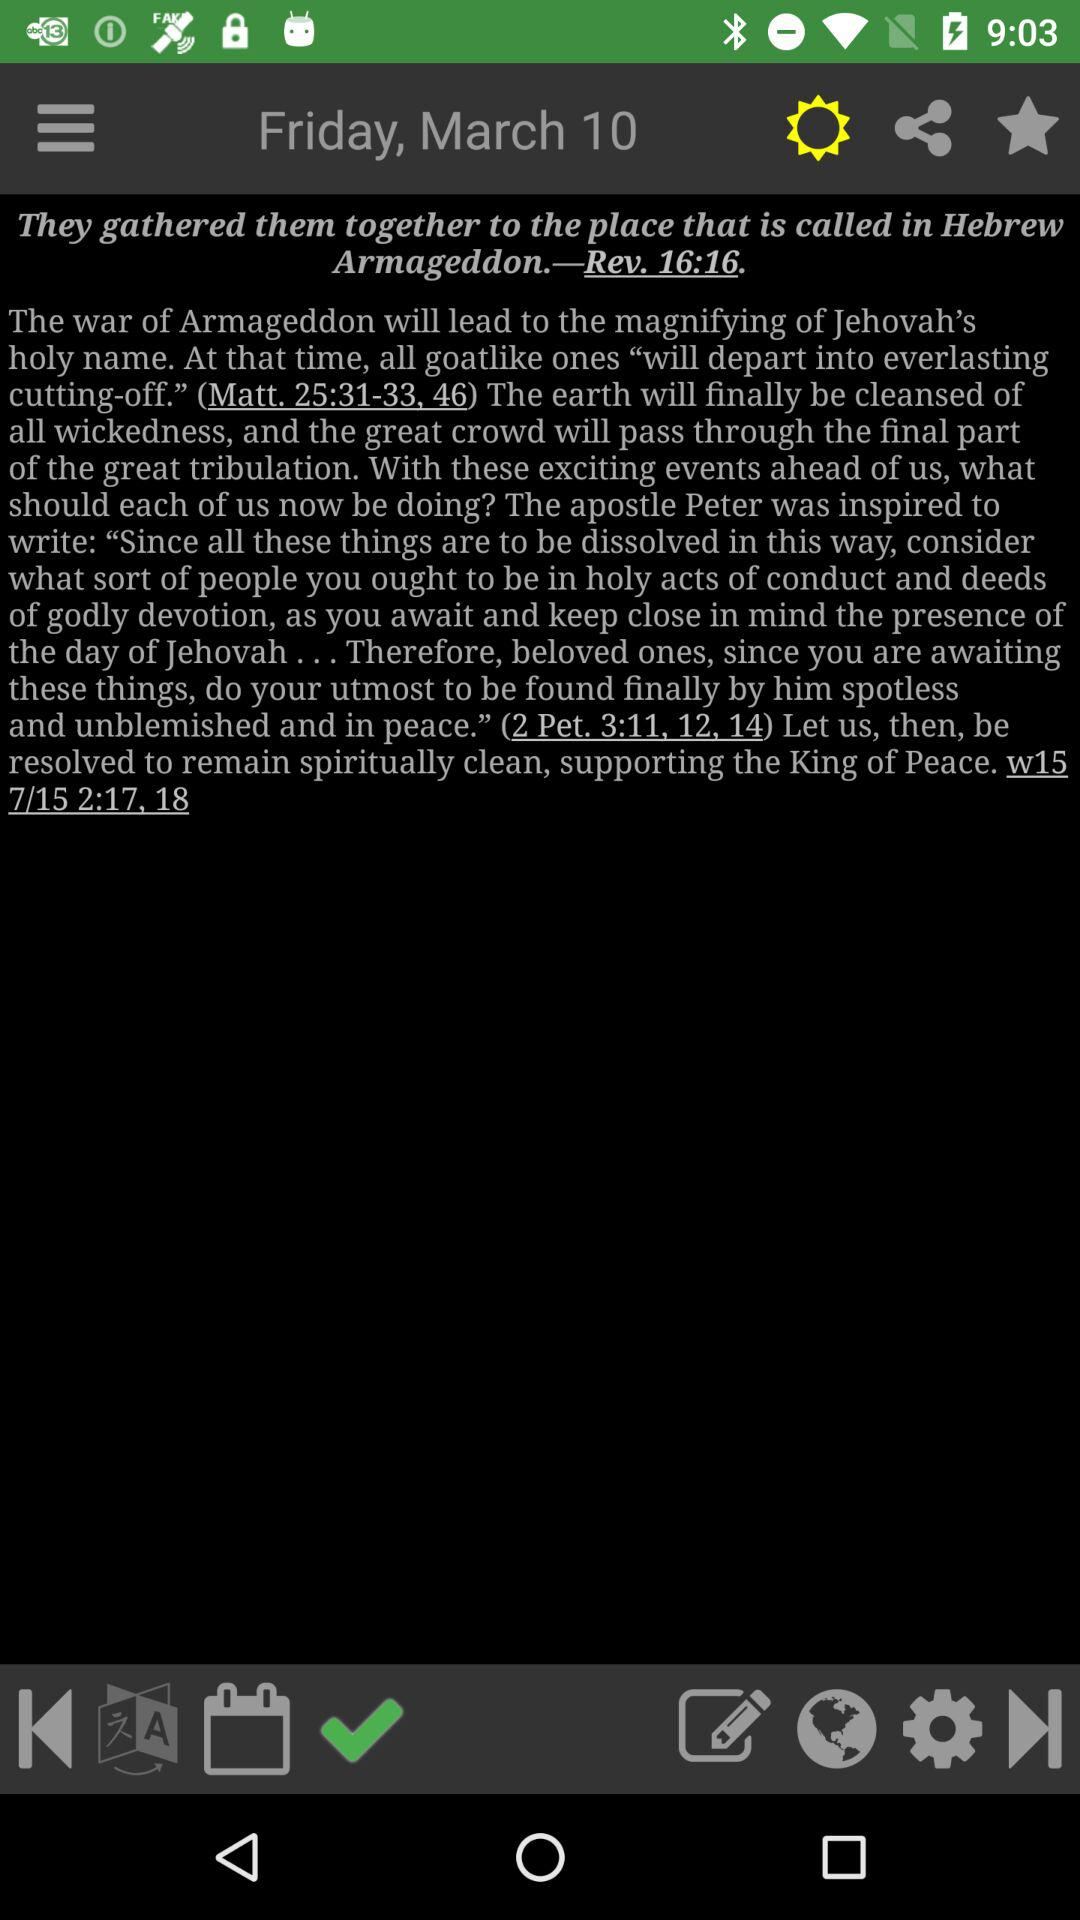What is the day? The day is Friday. 